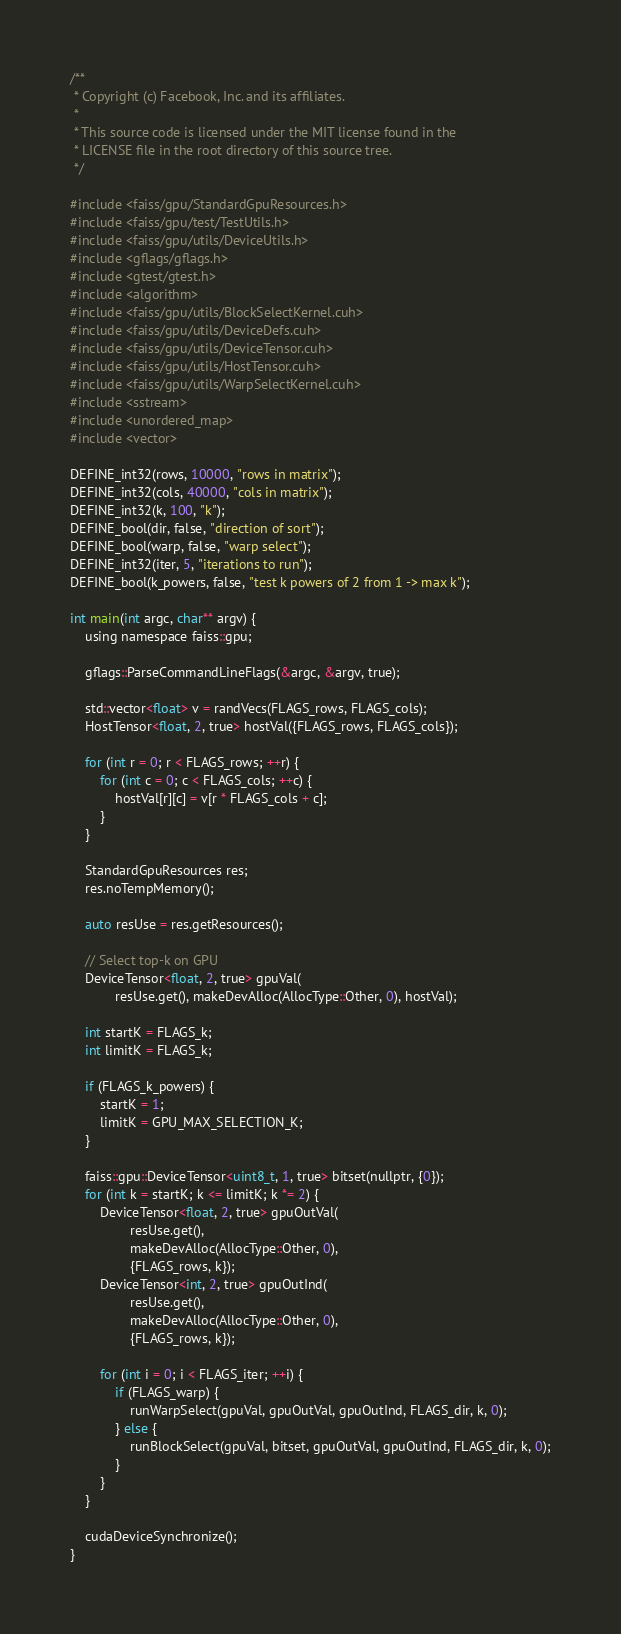<code> <loc_0><loc_0><loc_500><loc_500><_Cuda_>/**
 * Copyright (c) Facebook, Inc. and its affiliates.
 *
 * This source code is licensed under the MIT license found in the
 * LICENSE file in the root directory of this source tree.
 */

#include <faiss/gpu/StandardGpuResources.h>
#include <faiss/gpu/test/TestUtils.h>
#include <faiss/gpu/utils/DeviceUtils.h>
#include <gflags/gflags.h>
#include <gtest/gtest.h>
#include <algorithm>
#include <faiss/gpu/utils/BlockSelectKernel.cuh>
#include <faiss/gpu/utils/DeviceDefs.cuh>
#include <faiss/gpu/utils/DeviceTensor.cuh>
#include <faiss/gpu/utils/HostTensor.cuh>
#include <faiss/gpu/utils/WarpSelectKernel.cuh>
#include <sstream>
#include <unordered_map>
#include <vector>

DEFINE_int32(rows, 10000, "rows in matrix");
DEFINE_int32(cols, 40000, "cols in matrix");
DEFINE_int32(k, 100, "k");
DEFINE_bool(dir, false, "direction of sort");
DEFINE_bool(warp, false, "warp select");
DEFINE_int32(iter, 5, "iterations to run");
DEFINE_bool(k_powers, false, "test k powers of 2 from 1 -> max k");

int main(int argc, char** argv) {
    using namespace faiss::gpu;

    gflags::ParseCommandLineFlags(&argc, &argv, true);

    std::vector<float> v = randVecs(FLAGS_rows, FLAGS_cols);
    HostTensor<float, 2, true> hostVal({FLAGS_rows, FLAGS_cols});

    for (int r = 0; r < FLAGS_rows; ++r) {
        for (int c = 0; c < FLAGS_cols; ++c) {
            hostVal[r][c] = v[r * FLAGS_cols + c];
        }
    }

    StandardGpuResources res;
    res.noTempMemory();

    auto resUse = res.getResources();

    // Select top-k on GPU
    DeviceTensor<float, 2, true> gpuVal(
            resUse.get(), makeDevAlloc(AllocType::Other, 0), hostVal);

    int startK = FLAGS_k;
    int limitK = FLAGS_k;

    if (FLAGS_k_powers) {
        startK = 1;
        limitK = GPU_MAX_SELECTION_K;
    }

    faiss::gpu::DeviceTensor<uint8_t, 1, true> bitset(nullptr, {0});
    for (int k = startK; k <= limitK; k *= 2) {
        DeviceTensor<float, 2, true> gpuOutVal(
                resUse.get(),
                makeDevAlloc(AllocType::Other, 0),
                {FLAGS_rows, k});
        DeviceTensor<int, 2, true> gpuOutInd(
                resUse.get(),
                makeDevAlloc(AllocType::Other, 0),
                {FLAGS_rows, k});

        for (int i = 0; i < FLAGS_iter; ++i) {
            if (FLAGS_warp) {
                runWarpSelect(gpuVal, gpuOutVal, gpuOutInd, FLAGS_dir, k, 0);
            } else {
                runBlockSelect(gpuVal, bitset, gpuOutVal, gpuOutInd, FLAGS_dir, k, 0);
            }
        }
    }

    cudaDeviceSynchronize();
}
</code> 